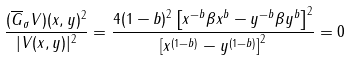Convert formula to latex. <formula><loc_0><loc_0><loc_500><loc_500>& \frac { \| ( \overline { G } _ { \sigma } V ) ( x , y ) \| ^ { 2 } } { | V ( x , y ) | ^ { 2 } } = \frac { 4 ( 1 - b ) ^ { 2 } \left [ x ^ { - b } \beta x ^ { b } - y ^ { - b } \beta y ^ { b } \right ] ^ { 2 } } { \left [ x ^ { ( 1 - b ) } - y ^ { ( 1 - b ) } \right ] ^ { 2 } } = 0</formula> 